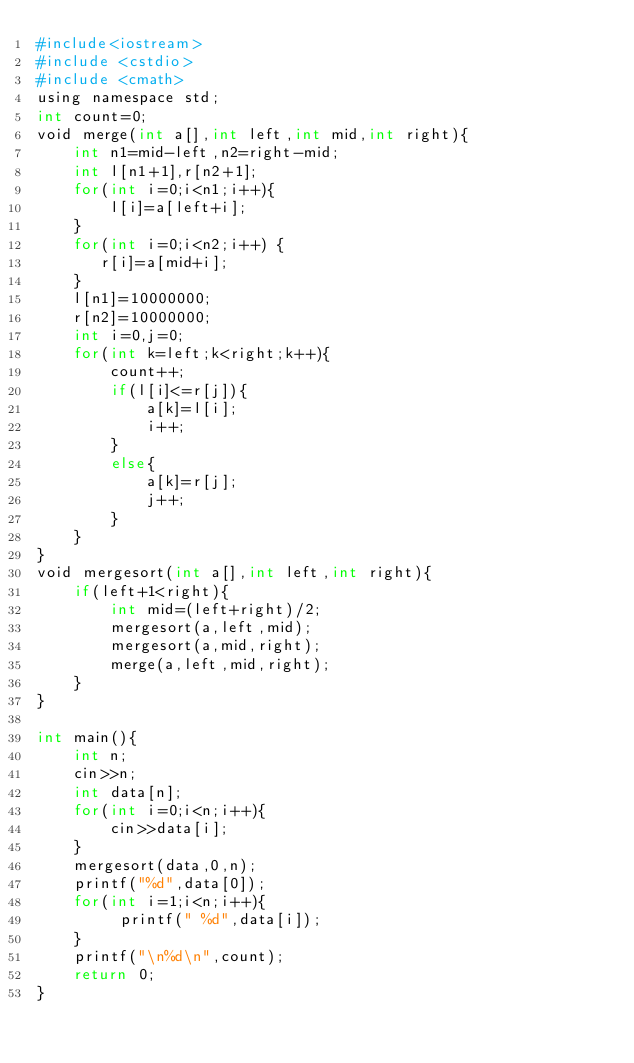<code> <loc_0><loc_0><loc_500><loc_500><_Python_>#include<iostream>
#include <cstdio>
#include <cmath>
using namespace std;
int count=0;
void merge(int a[],int left,int mid,int right){
    int n1=mid-left,n2=right-mid;
    int l[n1+1],r[n2+1];
    for(int i=0;i<n1;i++){
	    l[i]=a[left+i];
	}
    for(int i=0;i<n2;i++) {
	   r[i]=a[mid+i];
	}
    l[n1]=10000000; 
    r[n2]=10000000;
    int i=0,j=0;
    for(int k=left;k<right;k++){
        count++;
        if(l[i]<=r[j]){
            a[k]=l[i];
            i++;
        }
        else{
            a[k]=r[j];
            j++;
        }
    }
}
void mergesort(int a[],int left,int right){
    if(left+1<right){
        int mid=(left+right)/2;
        mergesort(a,left,mid);
        mergesort(a,mid,right);
        merge(a,left,mid,right);
    }
}
 
int main(){
    int n;  
    cin>>n;
    int data[n];
    for(int i=0;i<n;i++){
        cin>>data[i];
    }
    mergesort(data,0,n);
    printf("%d",data[0]);
    for(int i=1;i<n;i++){
		 printf(" %d",data[i]);
	}  
    printf("\n%d\n",count);
    return 0;
}
</code> 